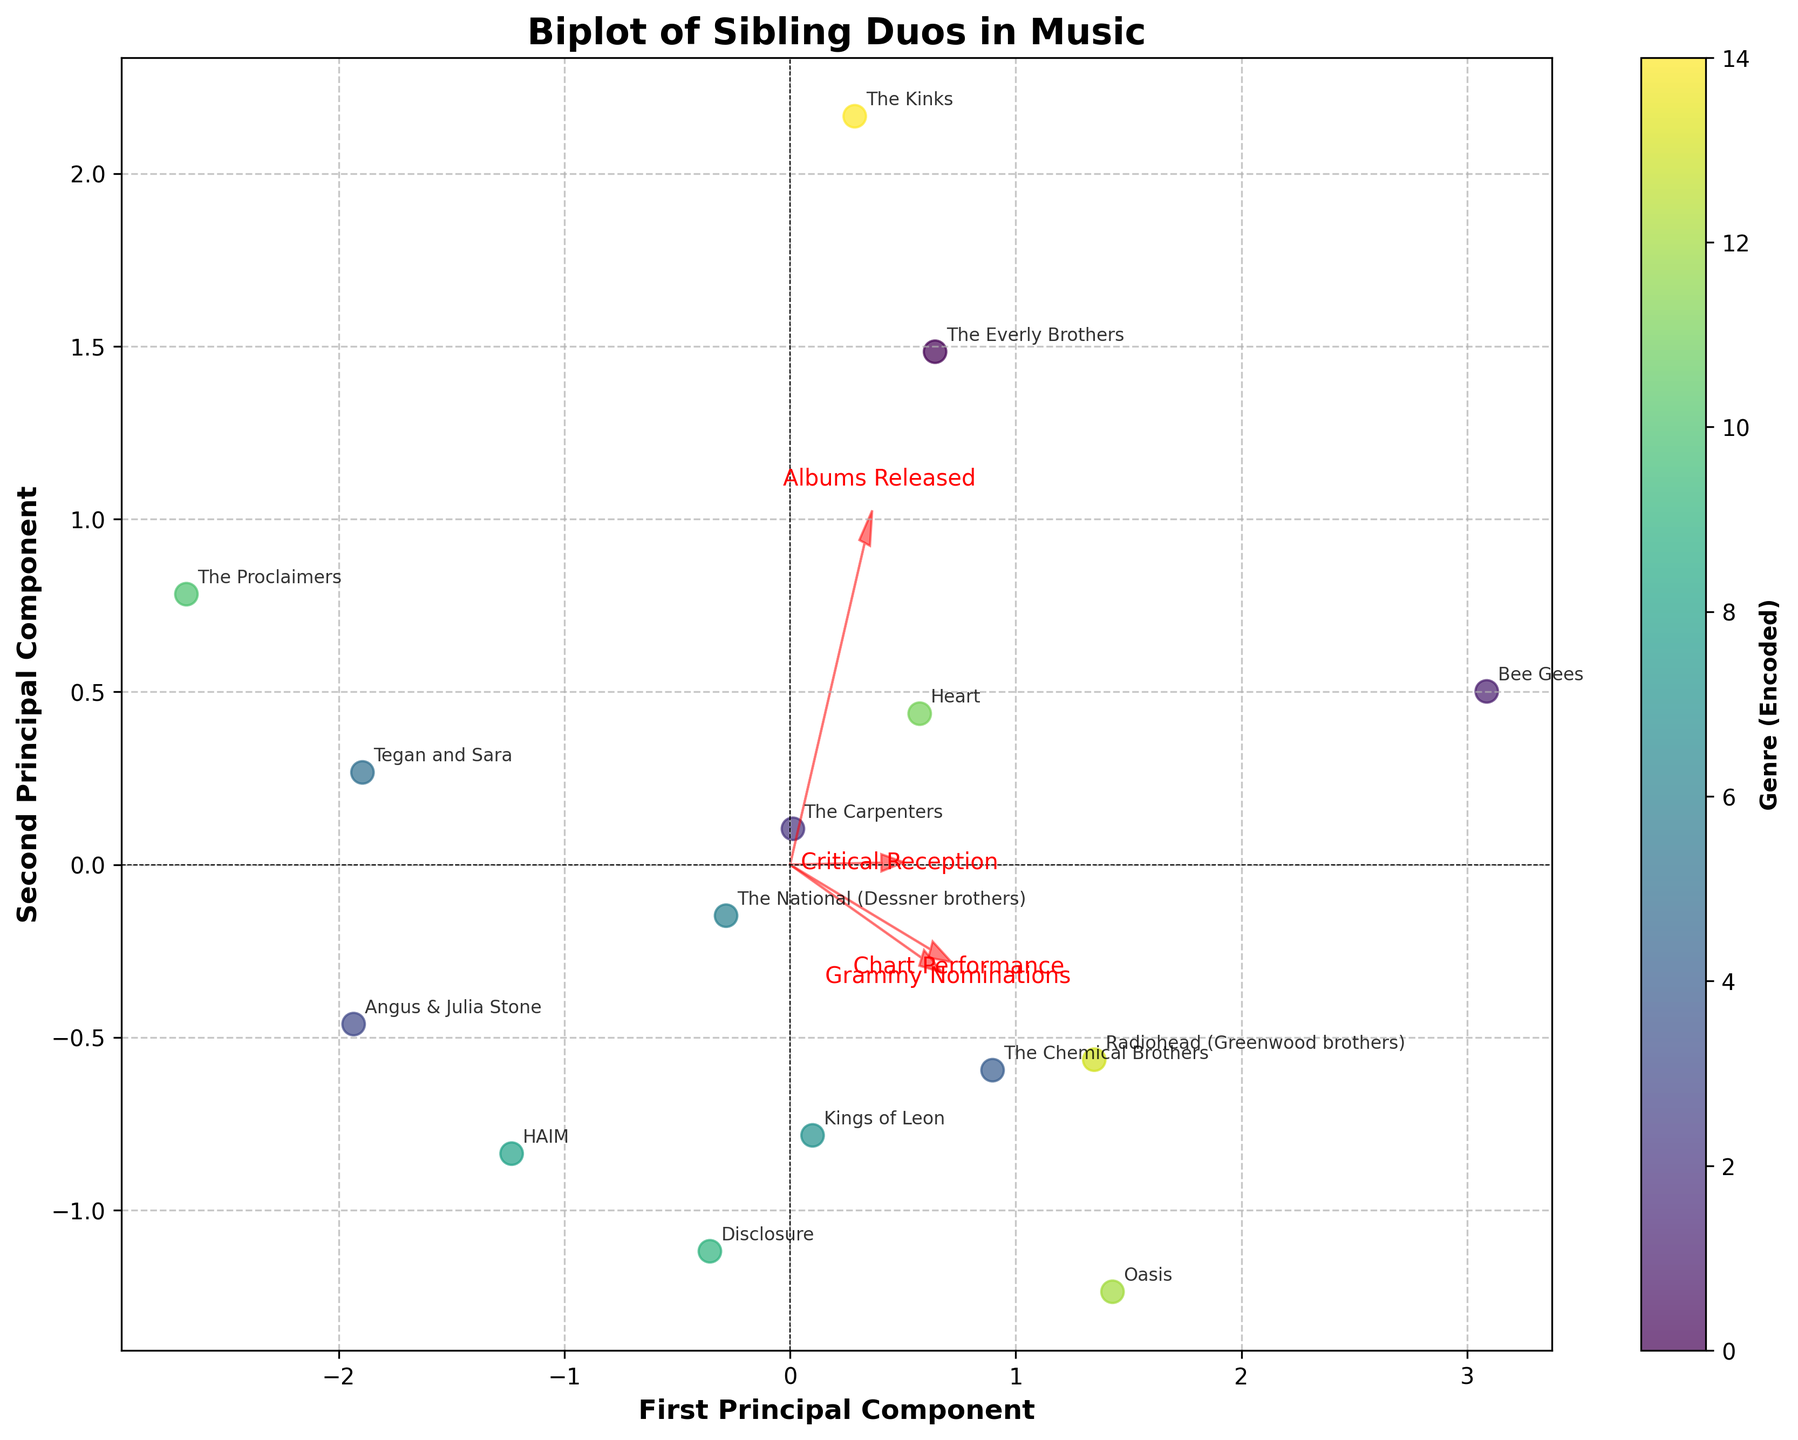What is the title of the plot? The title is prominently displayed at the top of the plot.
Answer: Biplot of Sibling Duos in Music Which artist duo is located farthest to the right on the plot? The artist duo farthest to the right can be identified by looking at the farthest point to the right side of the plot.
Answer: Bee Gees How does "Chart Performance" influence the positioning of the duos on the biplot? Looking at the direction of the "Chart Performance" arrow, artist duos with higher chart performance scores will be positioned more along this arrow.
Answer: Higher chart performance pushes points to the right Which duo has the highest critical reception, and where is its position relative to the axes? Identify the "Critical Reception" arrow’s direction and find the point farthest along it. Check its coordinates.
Answer: Radiohead (Greenwood brothers), located towards the top Are there more pop or rock genre duos depicted in the biplot? Count the number of duos categorized under each genre by visually inspecting their annotations.
Answer: More Rock duos Which artist duo stands out having a high number of Grammy nominations and how does this reflect in their positioning? The direction of the "Grammy Nominations" arrow will show which duo is farthest along it.
Answer: Bee Gees, positioned farthest in the direction of "Grammy Nominations" Compare the position of The Everly Brothers and The Carpenters on the plot. Which has better chart performance? Look at the relative positioning of The Everly Brothers and The Carpenters along the "Chart Performance" arrow.
Answer: The Everly Brothers Which genre appears to have the most balanced combination of chart performance and critical reception based on their positioning? Identify the duos that are most centrally located between the arrows for "Chart Performance" and "Critical Reception".
Answer: Pop Rock (HAIM) Identify the duo with the lowest chart performance. Provide its coordinates on the plot. Find the data point that is placed lowest along the "Chart Performance" arrow.
Answer: The Proclaimers, coordinates near the bottom left Based on the plot, which factors are most influential in determining the position of "The National (Dessner brothers)"? Observe the arrows pointing closest to The National’s position to determine the influencing factors.
Answer: Critical Reception and Albums Released 